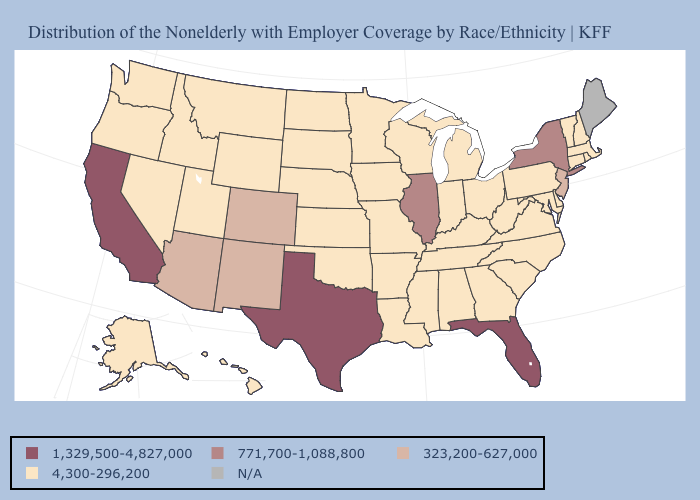Which states have the highest value in the USA?
Keep it brief. California, Florida, Texas. Among the states that border Wyoming , which have the lowest value?
Keep it brief. Idaho, Montana, Nebraska, South Dakota, Utah. Name the states that have a value in the range 4,300-296,200?
Short answer required. Alabama, Alaska, Arkansas, Connecticut, Delaware, Georgia, Hawaii, Idaho, Indiana, Iowa, Kansas, Kentucky, Louisiana, Maryland, Massachusetts, Michigan, Minnesota, Mississippi, Missouri, Montana, Nebraska, Nevada, New Hampshire, North Carolina, North Dakota, Ohio, Oklahoma, Oregon, Pennsylvania, Rhode Island, South Carolina, South Dakota, Tennessee, Utah, Vermont, Virginia, Washington, West Virginia, Wisconsin, Wyoming. Name the states that have a value in the range N/A?
Write a very short answer. Maine. What is the value of Alabama?
Quick response, please. 4,300-296,200. Does the first symbol in the legend represent the smallest category?
Answer briefly. No. What is the lowest value in states that border North Carolina?
Quick response, please. 4,300-296,200. Which states have the lowest value in the West?
Keep it brief. Alaska, Hawaii, Idaho, Montana, Nevada, Oregon, Utah, Washington, Wyoming. How many symbols are there in the legend?
Write a very short answer. 5. What is the value of Georgia?
Give a very brief answer. 4,300-296,200. What is the value of New Hampshire?
Quick response, please. 4,300-296,200. Which states have the lowest value in the MidWest?
Keep it brief. Indiana, Iowa, Kansas, Michigan, Minnesota, Missouri, Nebraska, North Dakota, Ohio, South Dakota, Wisconsin. 